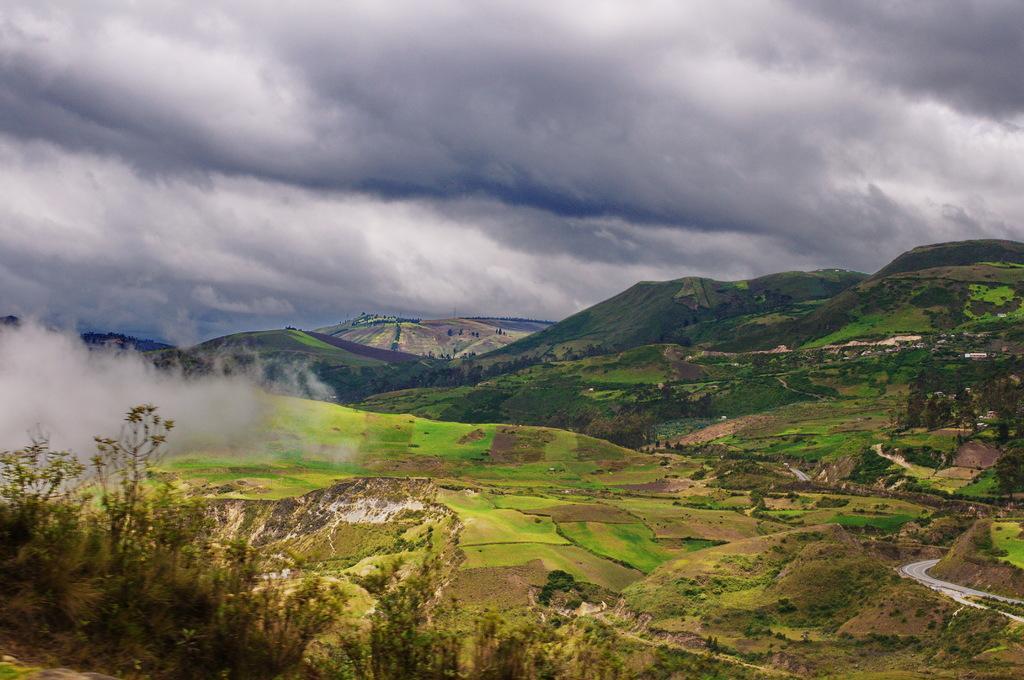Please provide a concise description of this image. In the background we can see clouds in the sky. In this picture we can see hills, trees and the thicket. 